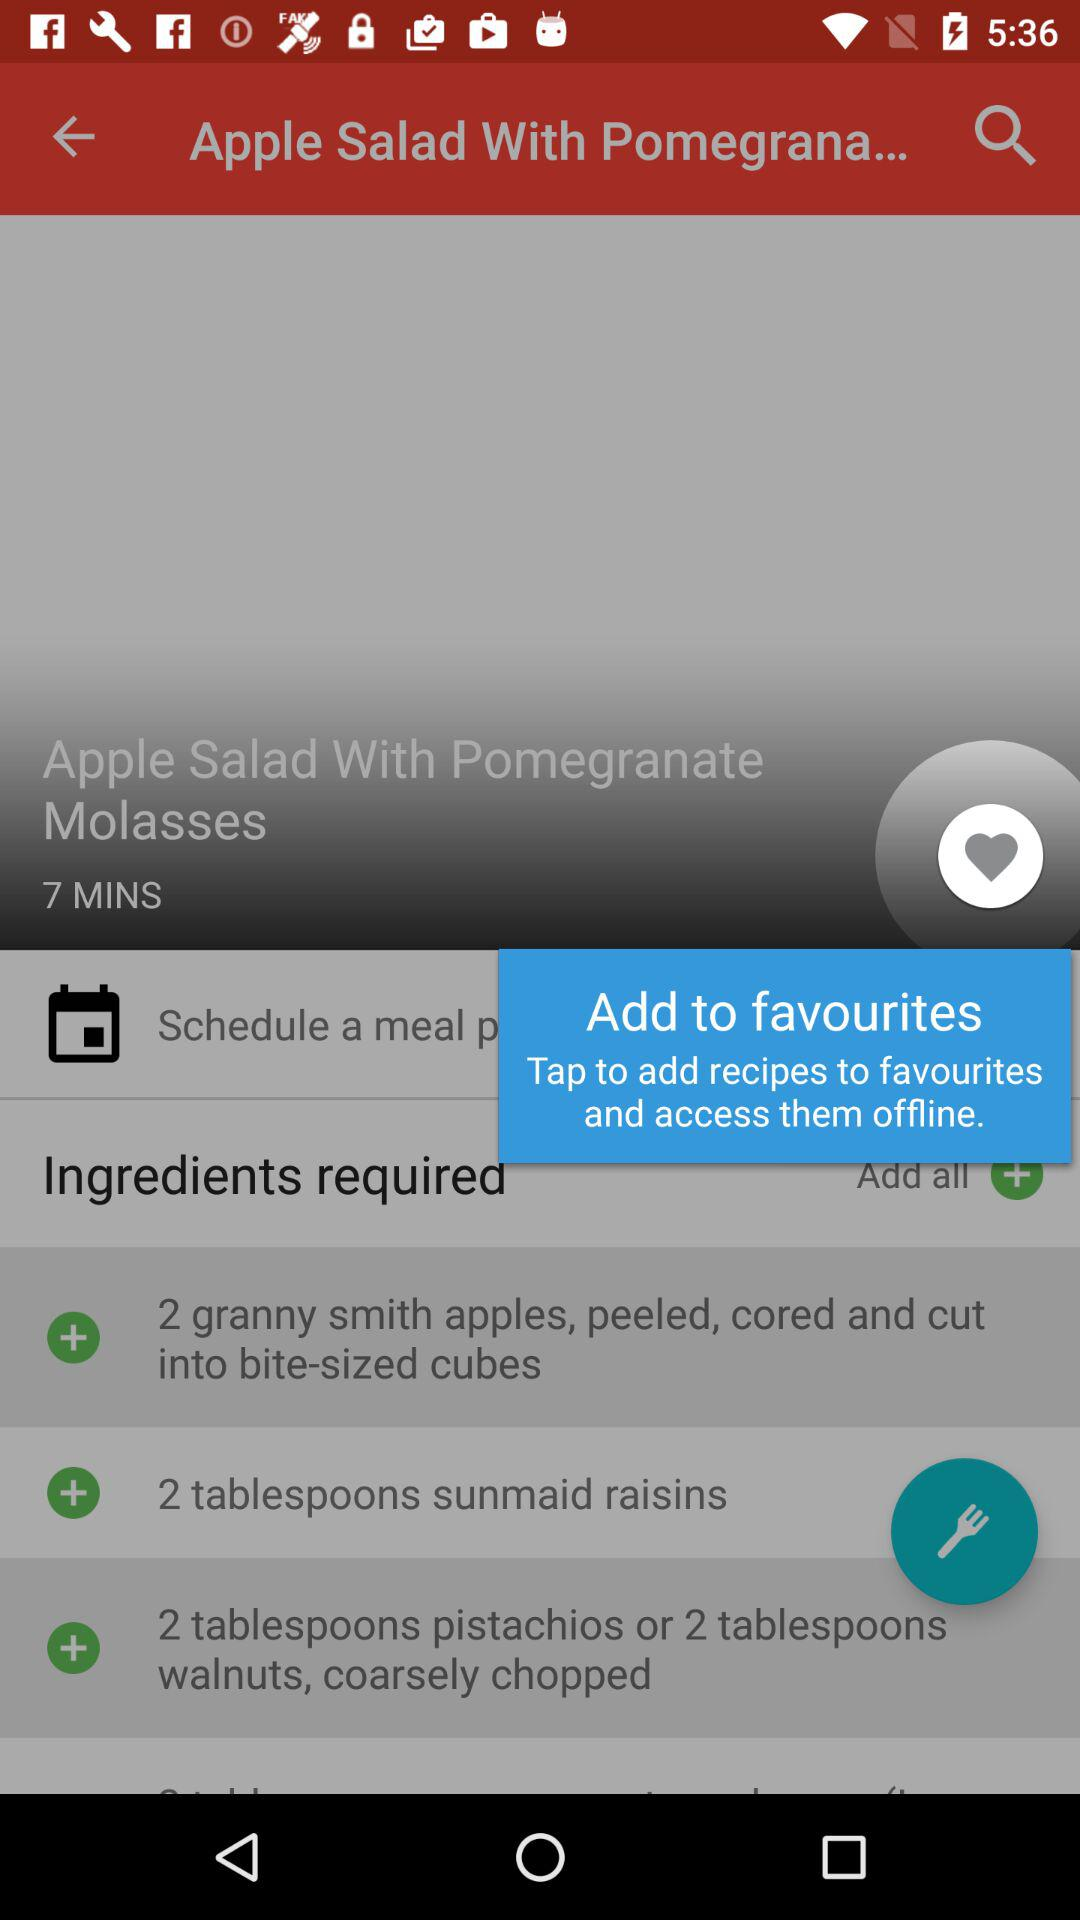How many ingredients are needed to make this recipe?
Answer the question using a single word or phrase. 3 